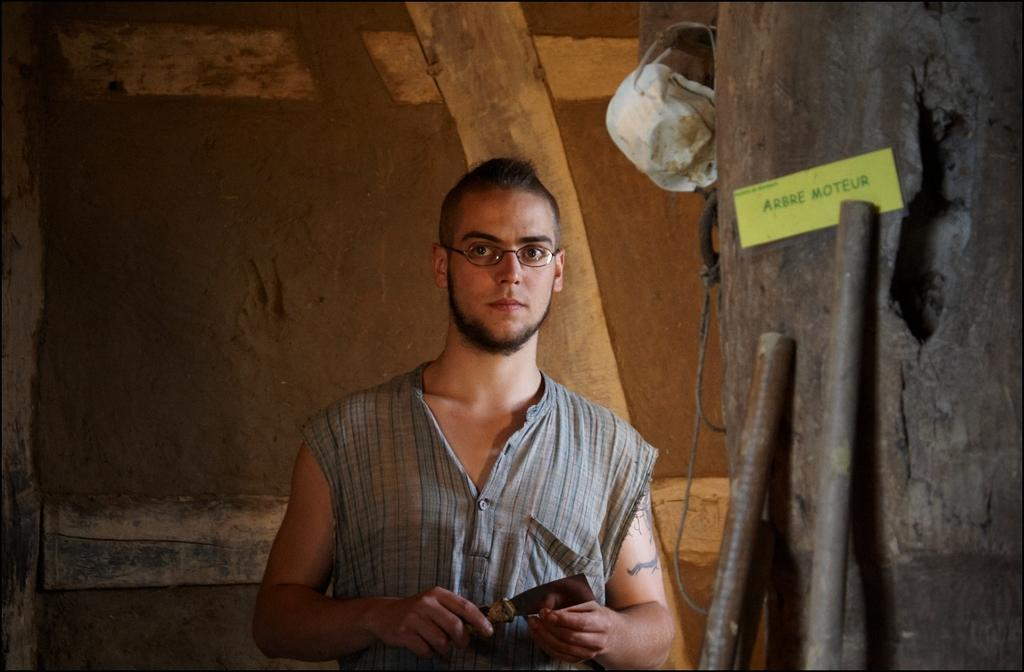What is the main subject of the image? There is a man in the image. What is the man doing in the image? The man is standing in the image. What object is the man holding? The man is holding a knife in the image. What can be seen on the ground in the image? There is a tree trunk and two rods placed on the tree trunk in the image. What type of structure is visible in the background? There is a wooden wall in the image. What type of oil is being used to cook the celery in the image? There is no celery or oil present in the image. 